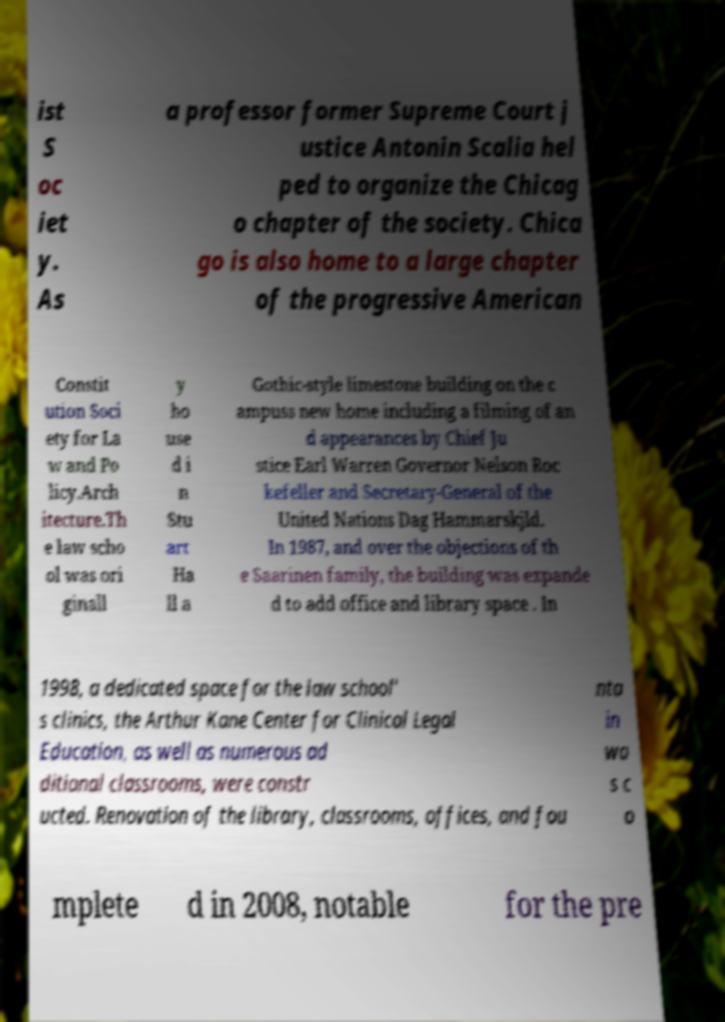There's text embedded in this image that I need extracted. Can you transcribe it verbatim? ist S oc iet y. As a professor former Supreme Court j ustice Antonin Scalia hel ped to organize the Chicag o chapter of the society. Chica go is also home to a large chapter of the progressive American Constit ution Soci ety for La w and Po licy.Arch itecture.Th e law scho ol was ori ginall y ho use d i n Stu art Ha ll a Gothic-style limestone building on the c ampuss new home including a filming of an d appearances by Chief Ju stice Earl Warren Governor Nelson Roc kefeller and Secretary-General of the United Nations Dag Hammarskjld. In 1987, and over the objections of th e Saarinen family, the building was expande d to add office and library space . In 1998, a dedicated space for the law school' s clinics, the Arthur Kane Center for Clinical Legal Education, as well as numerous ad ditional classrooms, were constr ucted. Renovation of the library, classrooms, offices, and fou nta in wa s c o mplete d in 2008, notable for the pre 